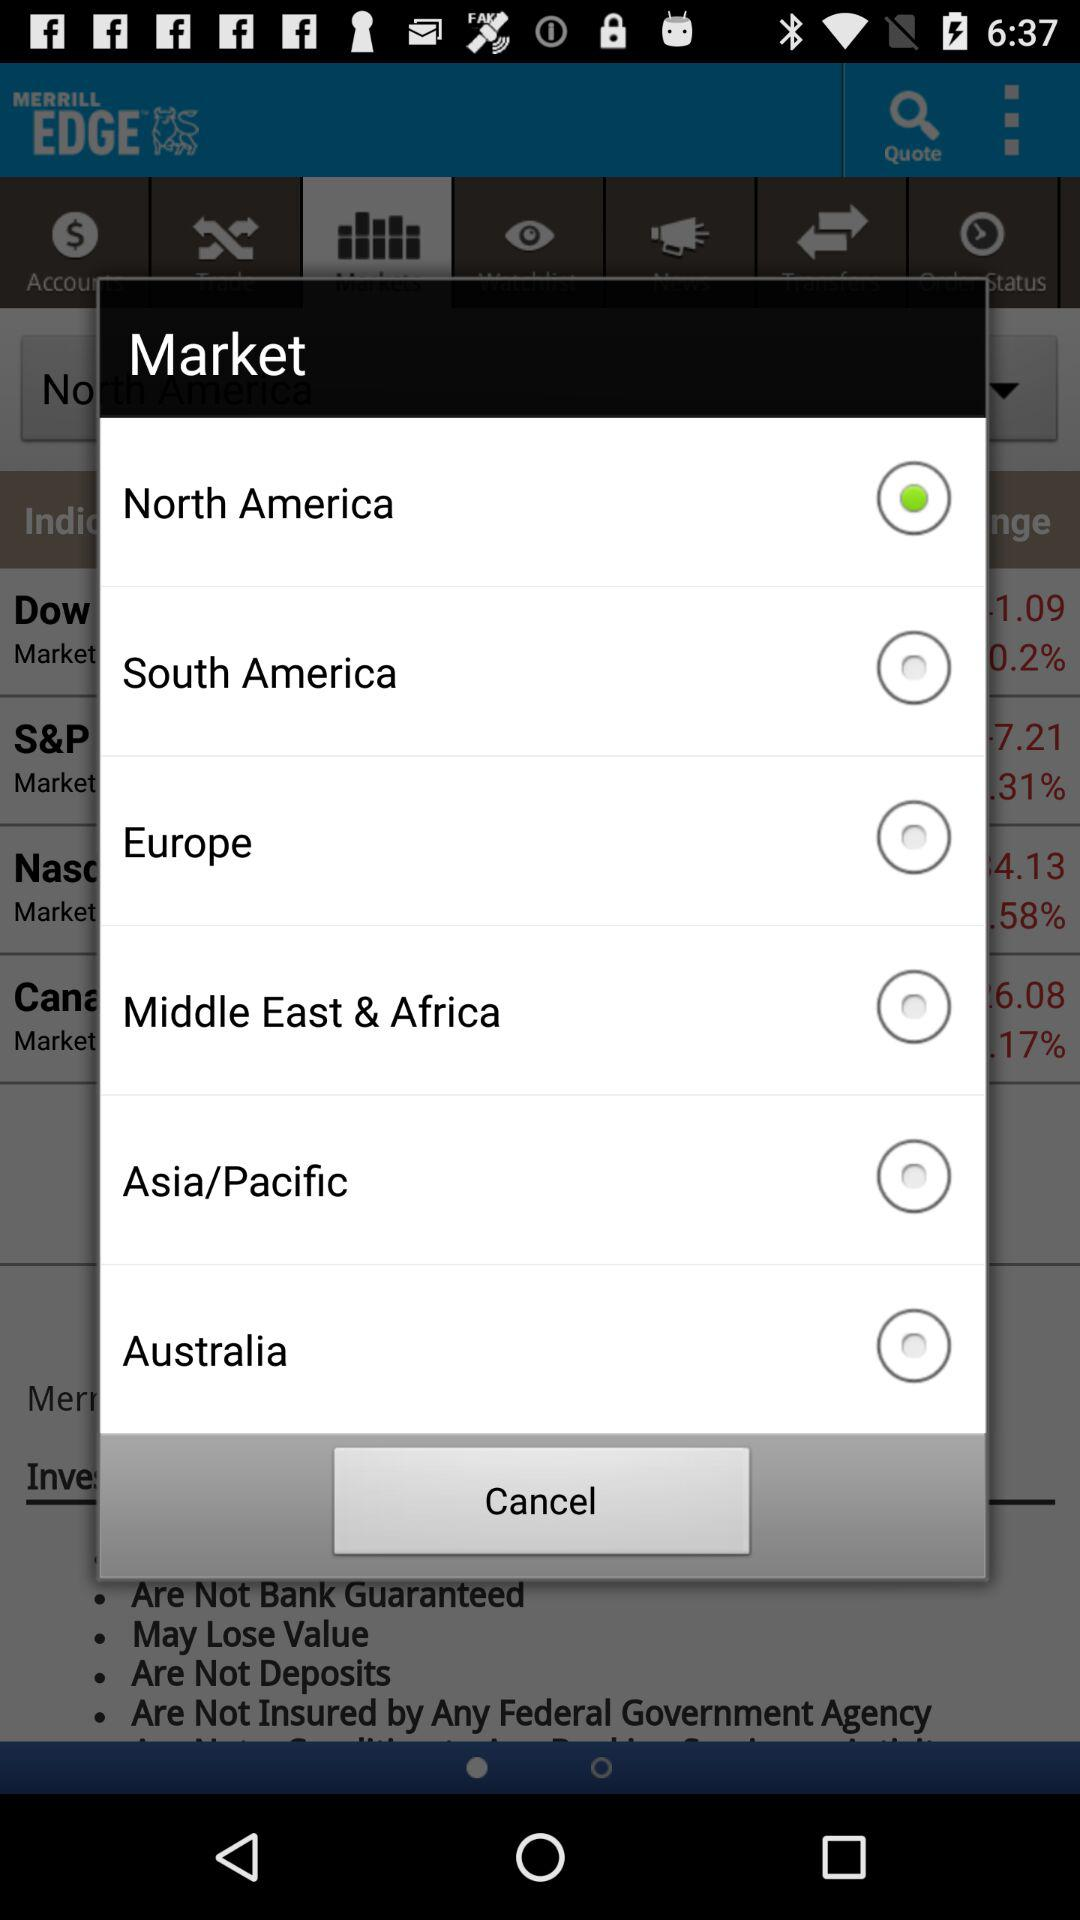How many markets are located in Asia/Pacific?
Answer the question using a single word or phrase. 1 